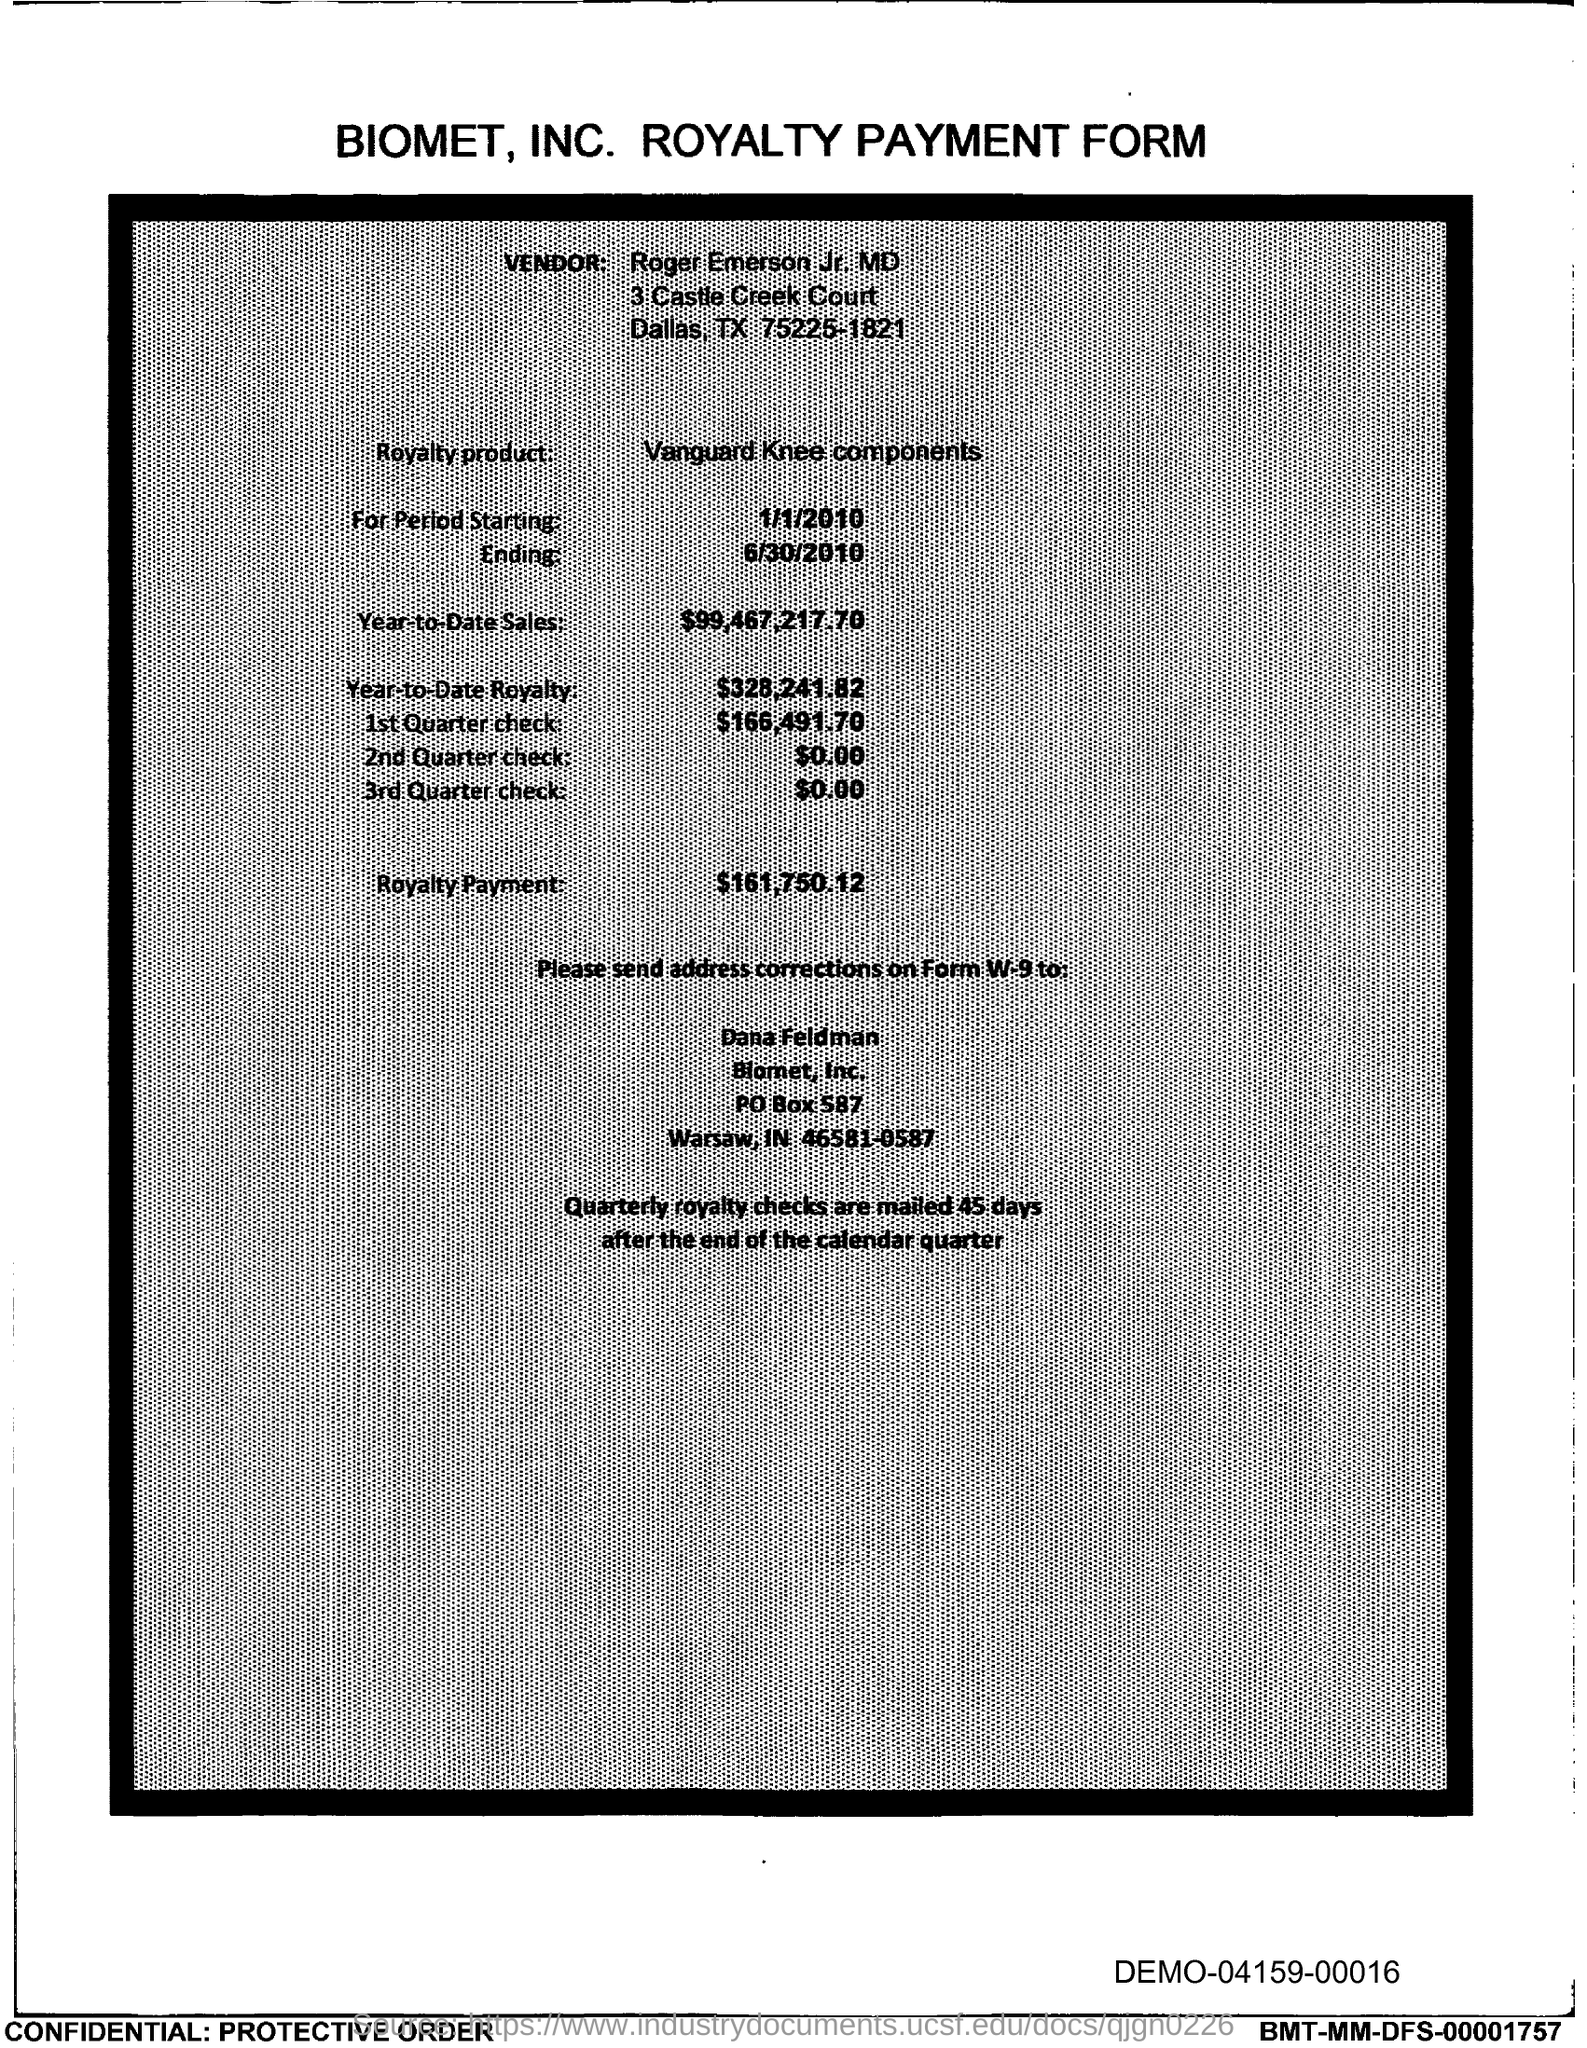What is the PO Box Number mentioned in the document?
Offer a terse response. 587. 